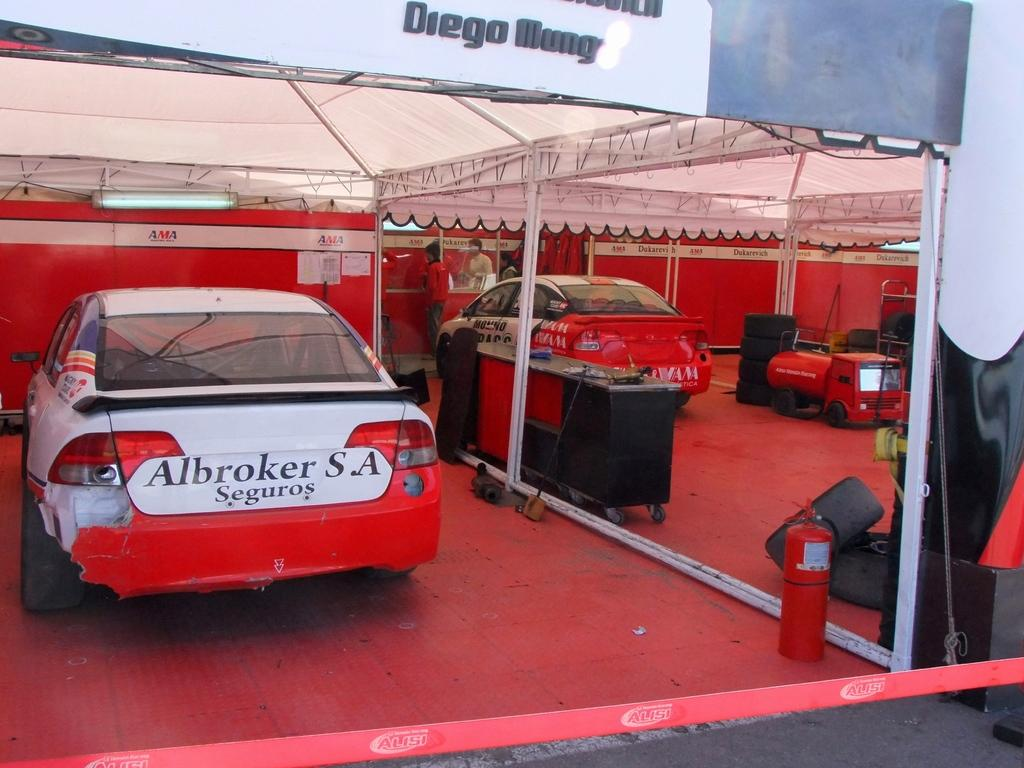What are the two cars doing in the image? The two cars are parked in a tent. What safety device is located on the path? There is a fire extinguisher on the path. What else can be found on the path besides the fire extinguisher? There are other unspecified things on the path. What type of finger can be seen pointing at the cars in the image? There are no fingers visible in the image, let alone pointing at the cars. 